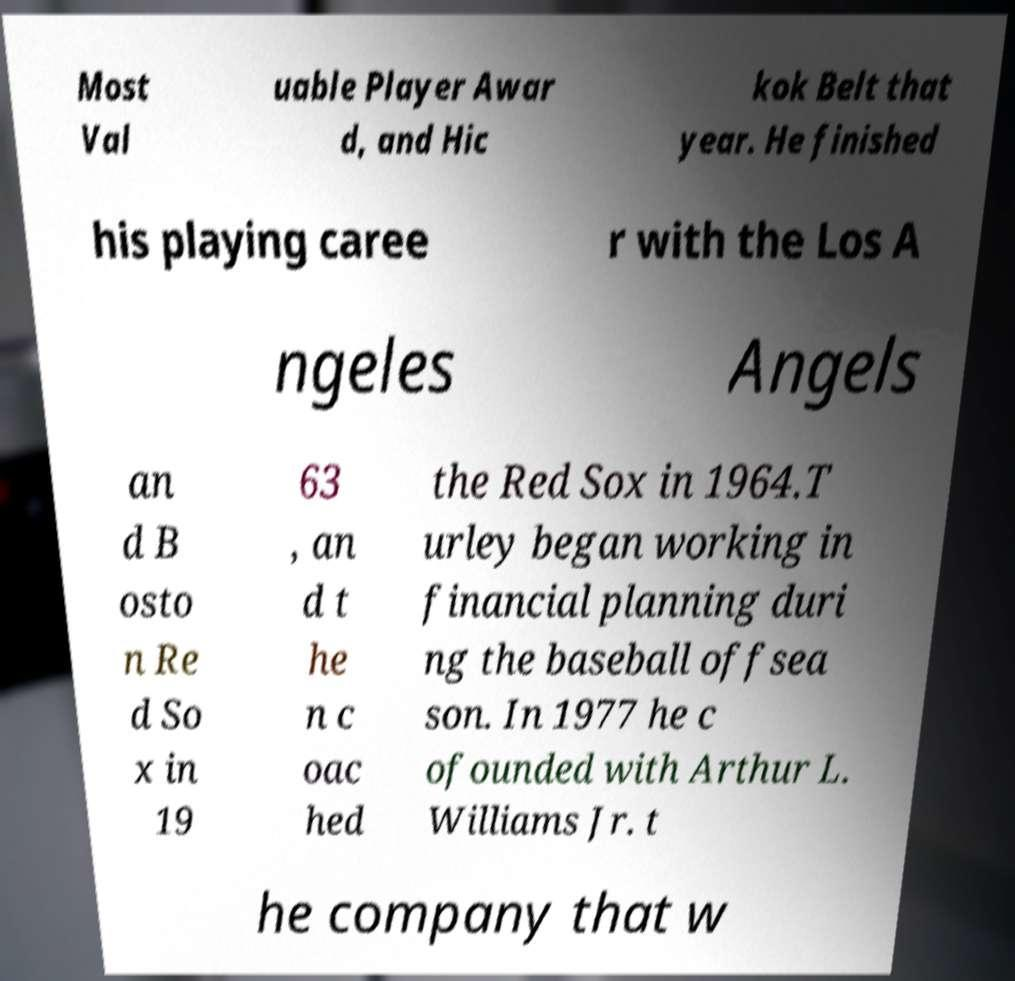For documentation purposes, I need the text within this image transcribed. Could you provide that? Most Val uable Player Awar d, and Hic kok Belt that year. He finished his playing caree r with the Los A ngeles Angels an d B osto n Re d So x in 19 63 , an d t he n c oac hed the Red Sox in 1964.T urley began working in financial planning duri ng the baseball offsea son. In 1977 he c ofounded with Arthur L. Williams Jr. t he company that w 